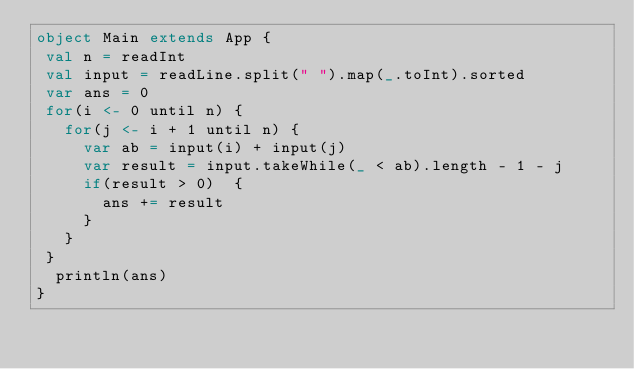<code> <loc_0><loc_0><loc_500><loc_500><_Scala_>object Main extends App {
 val n = readInt
 val input = readLine.split(" ").map(_.toInt).sorted
 var ans = 0
 for(i <- 0 until n) {
   for(j <- i + 1 until n) {
     var ab = input(i) + input(j)
     var result = input.takeWhile(_ < ab).length - 1 - j
     if(result > 0)  {
       ans += result
     }
   }
 }
  println(ans)  
}
</code> 